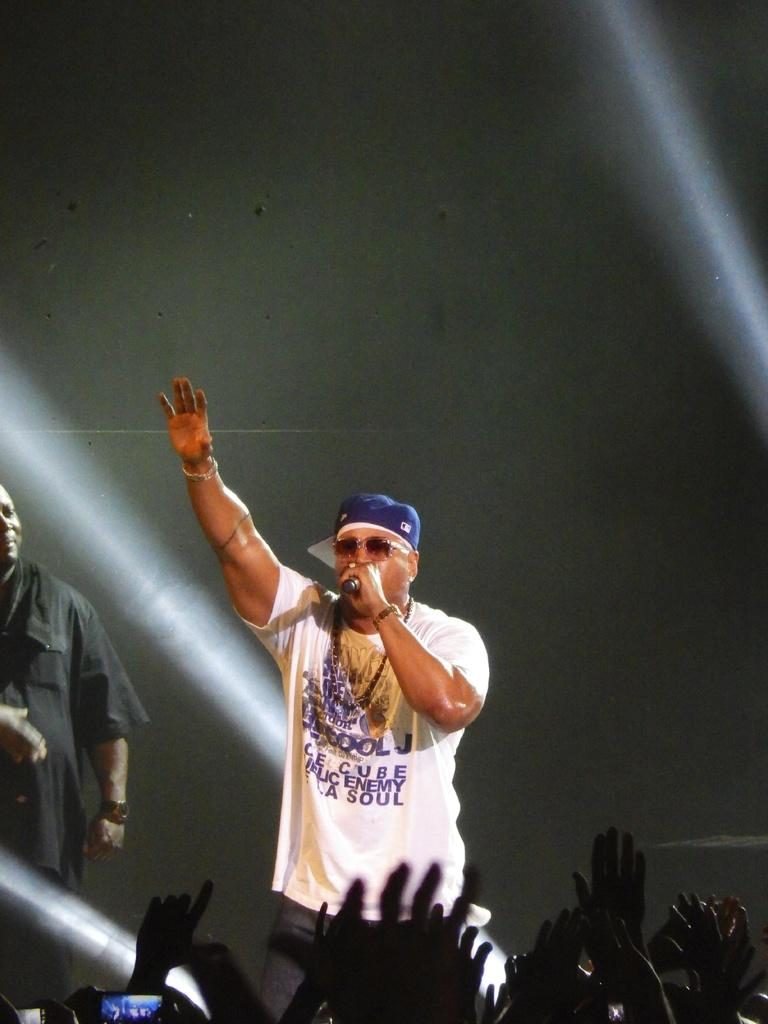<image>
Relay a brief, clear account of the picture shown. Man performing on stage with a shirt that says Enemy on it. 